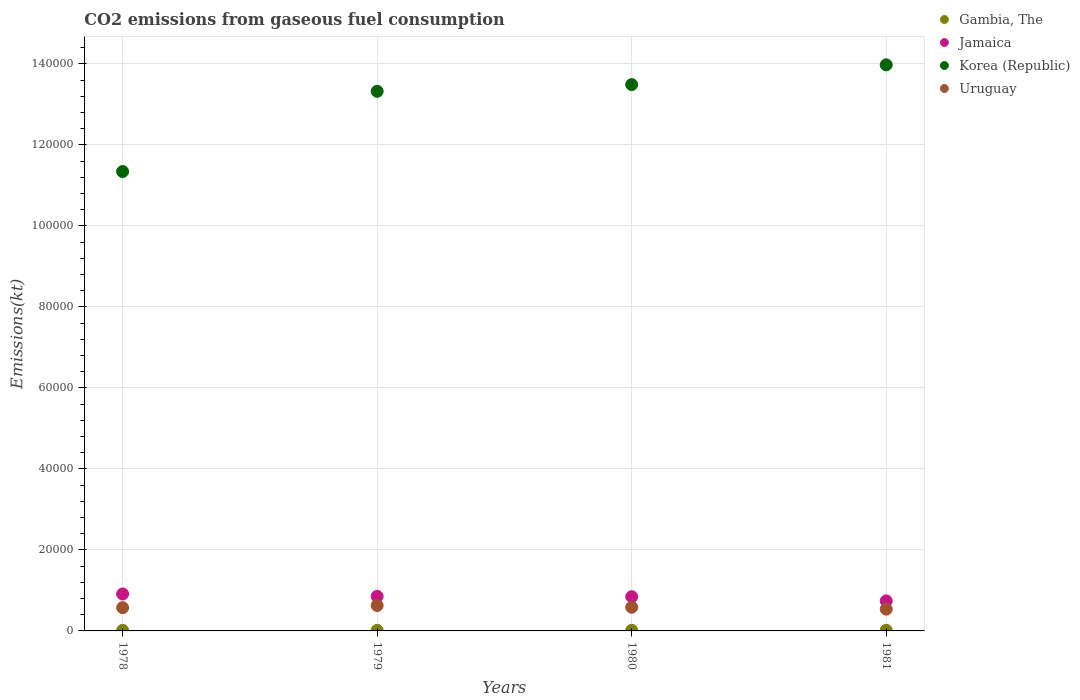What is the amount of CO2 emitted in Gambia, The in 1979?
Keep it short and to the point. 146.68. Across all years, what is the maximum amount of CO2 emitted in Gambia, The?
Your response must be concise. 157.68. Across all years, what is the minimum amount of CO2 emitted in Gambia, The?
Give a very brief answer. 139.35. In which year was the amount of CO2 emitted in Gambia, The maximum?
Provide a succinct answer. 1980. In which year was the amount of CO2 emitted in Gambia, The minimum?
Provide a succinct answer. 1978. What is the total amount of CO2 emitted in Gambia, The in the graph?
Provide a short and direct response. 601.39. What is the difference between the amount of CO2 emitted in Uruguay in 1978 and that in 1980?
Provide a succinct answer. -95.34. What is the difference between the amount of CO2 emitted in Uruguay in 1979 and the amount of CO2 emitted in Gambia, The in 1978?
Ensure brevity in your answer.  6138.56. What is the average amount of CO2 emitted in Jamaica per year?
Ensure brevity in your answer.  8380.93. In the year 1979, what is the difference between the amount of CO2 emitted in Korea (Republic) and amount of CO2 emitted in Jamaica?
Provide a succinct answer. 1.25e+05. What is the ratio of the amount of CO2 emitted in Gambia, The in 1978 to that in 1980?
Keep it short and to the point. 0.88. Is the amount of CO2 emitted in Gambia, The in 1979 less than that in 1980?
Your answer should be compact. Yes. What is the difference between the highest and the second highest amount of CO2 emitted in Jamaica?
Your answer should be compact. 583.05. What is the difference between the highest and the lowest amount of CO2 emitted in Jamaica?
Offer a terse response. 1705.15. In how many years, is the amount of CO2 emitted in Korea (Republic) greater than the average amount of CO2 emitted in Korea (Republic) taken over all years?
Offer a terse response. 3. Is the sum of the amount of CO2 emitted in Jamaica in 1979 and 1980 greater than the maximum amount of CO2 emitted in Korea (Republic) across all years?
Keep it short and to the point. No. Is it the case that in every year, the sum of the amount of CO2 emitted in Jamaica and amount of CO2 emitted in Uruguay  is greater than the amount of CO2 emitted in Korea (Republic)?
Offer a very short reply. No. Does the amount of CO2 emitted in Korea (Republic) monotonically increase over the years?
Make the answer very short. Yes. Is the amount of CO2 emitted in Gambia, The strictly greater than the amount of CO2 emitted in Uruguay over the years?
Provide a succinct answer. No. Is the amount of CO2 emitted in Jamaica strictly less than the amount of CO2 emitted in Uruguay over the years?
Provide a succinct answer. No. How many dotlines are there?
Ensure brevity in your answer.  4. What is the difference between two consecutive major ticks on the Y-axis?
Keep it short and to the point. 2.00e+04. Where does the legend appear in the graph?
Your response must be concise. Top right. How many legend labels are there?
Offer a very short reply. 4. How are the legend labels stacked?
Your response must be concise. Vertical. What is the title of the graph?
Offer a terse response. CO2 emissions from gaseous fuel consumption. Does "Hong Kong" appear as one of the legend labels in the graph?
Provide a short and direct response. No. What is the label or title of the Y-axis?
Provide a succinct answer. Emissions(kt). What is the Emissions(kt) of Gambia, The in 1978?
Offer a terse response. 139.35. What is the Emissions(kt) in Jamaica in 1978?
Make the answer very short. 9119.83. What is the Emissions(kt) in Korea (Republic) in 1978?
Offer a very short reply. 1.13e+05. What is the Emissions(kt) of Uruguay in 1978?
Your response must be concise. 5742.52. What is the Emissions(kt) of Gambia, The in 1979?
Make the answer very short. 146.68. What is the Emissions(kt) in Jamaica in 1979?
Provide a succinct answer. 8536.78. What is the Emissions(kt) in Korea (Republic) in 1979?
Provide a succinct answer. 1.33e+05. What is the Emissions(kt) of Uruguay in 1979?
Your response must be concise. 6277.9. What is the Emissions(kt) of Gambia, The in 1980?
Offer a terse response. 157.68. What is the Emissions(kt) of Jamaica in 1980?
Offer a very short reply. 8452.43. What is the Emissions(kt) in Korea (Republic) in 1980?
Your response must be concise. 1.35e+05. What is the Emissions(kt) of Uruguay in 1980?
Keep it short and to the point. 5837.86. What is the Emissions(kt) of Gambia, The in 1981?
Provide a short and direct response. 157.68. What is the Emissions(kt) of Jamaica in 1981?
Offer a very short reply. 7414.67. What is the Emissions(kt) of Korea (Republic) in 1981?
Offer a very short reply. 1.40e+05. What is the Emissions(kt) of Uruguay in 1981?
Offer a very short reply. 5375.82. Across all years, what is the maximum Emissions(kt) in Gambia, The?
Keep it short and to the point. 157.68. Across all years, what is the maximum Emissions(kt) in Jamaica?
Ensure brevity in your answer.  9119.83. Across all years, what is the maximum Emissions(kt) in Korea (Republic)?
Offer a terse response. 1.40e+05. Across all years, what is the maximum Emissions(kt) of Uruguay?
Keep it short and to the point. 6277.9. Across all years, what is the minimum Emissions(kt) in Gambia, The?
Ensure brevity in your answer.  139.35. Across all years, what is the minimum Emissions(kt) in Jamaica?
Your answer should be very brief. 7414.67. Across all years, what is the minimum Emissions(kt) in Korea (Republic)?
Offer a very short reply. 1.13e+05. Across all years, what is the minimum Emissions(kt) of Uruguay?
Provide a succinct answer. 5375.82. What is the total Emissions(kt) in Gambia, The in the graph?
Offer a very short reply. 601.39. What is the total Emissions(kt) in Jamaica in the graph?
Provide a succinct answer. 3.35e+04. What is the total Emissions(kt) of Korea (Republic) in the graph?
Your answer should be compact. 5.21e+05. What is the total Emissions(kt) in Uruguay in the graph?
Give a very brief answer. 2.32e+04. What is the difference between the Emissions(kt) in Gambia, The in 1978 and that in 1979?
Keep it short and to the point. -7.33. What is the difference between the Emissions(kt) of Jamaica in 1978 and that in 1979?
Make the answer very short. 583.05. What is the difference between the Emissions(kt) in Korea (Republic) in 1978 and that in 1979?
Make the answer very short. -1.98e+04. What is the difference between the Emissions(kt) of Uruguay in 1978 and that in 1979?
Keep it short and to the point. -535.38. What is the difference between the Emissions(kt) of Gambia, The in 1978 and that in 1980?
Provide a succinct answer. -18.34. What is the difference between the Emissions(kt) in Jamaica in 1978 and that in 1980?
Ensure brevity in your answer.  667.39. What is the difference between the Emissions(kt) of Korea (Republic) in 1978 and that in 1980?
Your answer should be compact. -2.15e+04. What is the difference between the Emissions(kt) in Uruguay in 1978 and that in 1980?
Offer a terse response. -95.34. What is the difference between the Emissions(kt) in Gambia, The in 1978 and that in 1981?
Your answer should be compact. -18.34. What is the difference between the Emissions(kt) in Jamaica in 1978 and that in 1981?
Make the answer very short. 1705.15. What is the difference between the Emissions(kt) of Korea (Republic) in 1978 and that in 1981?
Your answer should be very brief. -2.63e+04. What is the difference between the Emissions(kt) in Uruguay in 1978 and that in 1981?
Keep it short and to the point. 366.7. What is the difference between the Emissions(kt) in Gambia, The in 1979 and that in 1980?
Offer a very short reply. -11. What is the difference between the Emissions(kt) in Jamaica in 1979 and that in 1980?
Make the answer very short. 84.34. What is the difference between the Emissions(kt) in Korea (Republic) in 1979 and that in 1980?
Make the answer very short. -1657.48. What is the difference between the Emissions(kt) of Uruguay in 1979 and that in 1980?
Your answer should be very brief. 440.04. What is the difference between the Emissions(kt) of Gambia, The in 1979 and that in 1981?
Make the answer very short. -11. What is the difference between the Emissions(kt) of Jamaica in 1979 and that in 1981?
Give a very brief answer. 1122.1. What is the difference between the Emissions(kt) in Korea (Republic) in 1979 and that in 1981?
Provide a short and direct response. -6530.93. What is the difference between the Emissions(kt) in Uruguay in 1979 and that in 1981?
Give a very brief answer. 902.08. What is the difference between the Emissions(kt) of Jamaica in 1980 and that in 1981?
Ensure brevity in your answer.  1037.76. What is the difference between the Emissions(kt) of Korea (Republic) in 1980 and that in 1981?
Ensure brevity in your answer.  -4873.44. What is the difference between the Emissions(kt) of Uruguay in 1980 and that in 1981?
Make the answer very short. 462.04. What is the difference between the Emissions(kt) of Gambia, The in 1978 and the Emissions(kt) of Jamaica in 1979?
Provide a short and direct response. -8397.43. What is the difference between the Emissions(kt) in Gambia, The in 1978 and the Emissions(kt) in Korea (Republic) in 1979?
Give a very brief answer. -1.33e+05. What is the difference between the Emissions(kt) of Gambia, The in 1978 and the Emissions(kt) of Uruguay in 1979?
Give a very brief answer. -6138.56. What is the difference between the Emissions(kt) of Jamaica in 1978 and the Emissions(kt) of Korea (Republic) in 1979?
Give a very brief answer. -1.24e+05. What is the difference between the Emissions(kt) of Jamaica in 1978 and the Emissions(kt) of Uruguay in 1979?
Your answer should be very brief. 2841.93. What is the difference between the Emissions(kt) in Korea (Republic) in 1978 and the Emissions(kt) in Uruguay in 1979?
Ensure brevity in your answer.  1.07e+05. What is the difference between the Emissions(kt) in Gambia, The in 1978 and the Emissions(kt) in Jamaica in 1980?
Your answer should be compact. -8313.09. What is the difference between the Emissions(kt) in Gambia, The in 1978 and the Emissions(kt) in Korea (Republic) in 1980?
Offer a very short reply. -1.35e+05. What is the difference between the Emissions(kt) in Gambia, The in 1978 and the Emissions(kt) in Uruguay in 1980?
Give a very brief answer. -5698.52. What is the difference between the Emissions(kt) of Jamaica in 1978 and the Emissions(kt) of Korea (Republic) in 1980?
Offer a terse response. -1.26e+05. What is the difference between the Emissions(kt) of Jamaica in 1978 and the Emissions(kt) of Uruguay in 1980?
Your response must be concise. 3281.97. What is the difference between the Emissions(kt) of Korea (Republic) in 1978 and the Emissions(kt) of Uruguay in 1980?
Your answer should be compact. 1.08e+05. What is the difference between the Emissions(kt) of Gambia, The in 1978 and the Emissions(kt) of Jamaica in 1981?
Your response must be concise. -7275.33. What is the difference between the Emissions(kt) of Gambia, The in 1978 and the Emissions(kt) of Korea (Republic) in 1981?
Ensure brevity in your answer.  -1.40e+05. What is the difference between the Emissions(kt) of Gambia, The in 1978 and the Emissions(kt) of Uruguay in 1981?
Provide a succinct answer. -5236.48. What is the difference between the Emissions(kt) in Jamaica in 1978 and the Emissions(kt) in Korea (Republic) in 1981?
Keep it short and to the point. -1.31e+05. What is the difference between the Emissions(kt) in Jamaica in 1978 and the Emissions(kt) in Uruguay in 1981?
Offer a terse response. 3744.01. What is the difference between the Emissions(kt) of Korea (Republic) in 1978 and the Emissions(kt) of Uruguay in 1981?
Your answer should be very brief. 1.08e+05. What is the difference between the Emissions(kt) of Gambia, The in 1979 and the Emissions(kt) of Jamaica in 1980?
Provide a succinct answer. -8305.75. What is the difference between the Emissions(kt) in Gambia, The in 1979 and the Emissions(kt) in Korea (Republic) in 1980?
Your answer should be very brief. -1.35e+05. What is the difference between the Emissions(kt) of Gambia, The in 1979 and the Emissions(kt) of Uruguay in 1980?
Your answer should be compact. -5691.18. What is the difference between the Emissions(kt) in Jamaica in 1979 and the Emissions(kt) in Korea (Republic) in 1980?
Provide a succinct answer. -1.26e+05. What is the difference between the Emissions(kt) of Jamaica in 1979 and the Emissions(kt) of Uruguay in 1980?
Provide a succinct answer. 2698.91. What is the difference between the Emissions(kt) of Korea (Republic) in 1979 and the Emissions(kt) of Uruguay in 1980?
Offer a very short reply. 1.27e+05. What is the difference between the Emissions(kt) in Gambia, The in 1979 and the Emissions(kt) in Jamaica in 1981?
Provide a succinct answer. -7267.99. What is the difference between the Emissions(kt) of Gambia, The in 1979 and the Emissions(kt) of Korea (Republic) in 1981?
Your answer should be very brief. -1.40e+05. What is the difference between the Emissions(kt) in Gambia, The in 1979 and the Emissions(kt) in Uruguay in 1981?
Provide a short and direct response. -5229.14. What is the difference between the Emissions(kt) of Jamaica in 1979 and the Emissions(kt) of Korea (Republic) in 1981?
Ensure brevity in your answer.  -1.31e+05. What is the difference between the Emissions(kt) of Jamaica in 1979 and the Emissions(kt) of Uruguay in 1981?
Give a very brief answer. 3160.95. What is the difference between the Emissions(kt) of Korea (Republic) in 1979 and the Emissions(kt) of Uruguay in 1981?
Offer a very short reply. 1.28e+05. What is the difference between the Emissions(kt) of Gambia, The in 1980 and the Emissions(kt) of Jamaica in 1981?
Your response must be concise. -7256.99. What is the difference between the Emissions(kt) of Gambia, The in 1980 and the Emissions(kt) of Korea (Republic) in 1981?
Provide a succinct answer. -1.40e+05. What is the difference between the Emissions(kt) of Gambia, The in 1980 and the Emissions(kt) of Uruguay in 1981?
Your response must be concise. -5218.14. What is the difference between the Emissions(kt) of Jamaica in 1980 and the Emissions(kt) of Korea (Republic) in 1981?
Your response must be concise. -1.31e+05. What is the difference between the Emissions(kt) in Jamaica in 1980 and the Emissions(kt) in Uruguay in 1981?
Give a very brief answer. 3076.61. What is the difference between the Emissions(kt) of Korea (Republic) in 1980 and the Emissions(kt) of Uruguay in 1981?
Provide a short and direct response. 1.29e+05. What is the average Emissions(kt) in Gambia, The per year?
Your response must be concise. 150.35. What is the average Emissions(kt) of Jamaica per year?
Make the answer very short. 8380.93. What is the average Emissions(kt) in Korea (Republic) per year?
Make the answer very short. 1.30e+05. What is the average Emissions(kt) of Uruguay per year?
Your response must be concise. 5808.53. In the year 1978, what is the difference between the Emissions(kt) in Gambia, The and Emissions(kt) in Jamaica?
Give a very brief answer. -8980.48. In the year 1978, what is the difference between the Emissions(kt) in Gambia, The and Emissions(kt) in Korea (Republic)?
Your answer should be compact. -1.13e+05. In the year 1978, what is the difference between the Emissions(kt) in Gambia, The and Emissions(kt) in Uruguay?
Provide a succinct answer. -5603.18. In the year 1978, what is the difference between the Emissions(kt) in Jamaica and Emissions(kt) in Korea (Republic)?
Your answer should be compact. -1.04e+05. In the year 1978, what is the difference between the Emissions(kt) of Jamaica and Emissions(kt) of Uruguay?
Your answer should be very brief. 3377.31. In the year 1978, what is the difference between the Emissions(kt) in Korea (Republic) and Emissions(kt) in Uruguay?
Provide a succinct answer. 1.08e+05. In the year 1979, what is the difference between the Emissions(kt) in Gambia, The and Emissions(kt) in Jamaica?
Ensure brevity in your answer.  -8390.1. In the year 1979, what is the difference between the Emissions(kt) of Gambia, The and Emissions(kt) of Korea (Republic)?
Offer a very short reply. -1.33e+05. In the year 1979, what is the difference between the Emissions(kt) in Gambia, The and Emissions(kt) in Uruguay?
Provide a short and direct response. -6131.22. In the year 1979, what is the difference between the Emissions(kt) in Jamaica and Emissions(kt) in Korea (Republic)?
Ensure brevity in your answer.  -1.25e+05. In the year 1979, what is the difference between the Emissions(kt) in Jamaica and Emissions(kt) in Uruguay?
Offer a terse response. 2258.87. In the year 1979, what is the difference between the Emissions(kt) in Korea (Republic) and Emissions(kt) in Uruguay?
Offer a very short reply. 1.27e+05. In the year 1980, what is the difference between the Emissions(kt) of Gambia, The and Emissions(kt) of Jamaica?
Keep it short and to the point. -8294.75. In the year 1980, what is the difference between the Emissions(kt) of Gambia, The and Emissions(kt) of Korea (Republic)?
Make the answer very short. -1.35e+05. In the year 1980, what is the difference between the Emissions(kt) in Gambia, The and Emissions(kt) in Uruguay?
Your response must be concise. -5680.18. In the year 1980, what is the difference between the Emissions(kt) in Jamaica and Emissions(kt) in Korea (Republic)?
Provide a succinct answer. -1.26e+05. In the year 1980, what is the difference between the Emissions(kt) in Jamaica and Emissions(kt) in Uruguay?
Provide a succinct answer. 2614.57. In the year 1980, what is the difference between the Emissions(kt) in Korea (Republic) and Emissions(kt) in Uruguay?
Offer a terse response. 1.29e+05. In the year 1981, what is the difference between the Emissions(kt) in Gambia, The and Emissions(kt) in Jamaica?
Offer a very short reply. -7256.99. In the year 1981, what is the difference between the Emissions(kt) of Gambia, The and Emissions(kt) of Korea (Republic)?
Your answer should be compact. -1.40e+05. In the year 1981, what is the difference between the Emissions(kt) in Gambia, The and Emissions(kt) in Uruguay?
Your answer should be very brief. -5218.14. In the year 1981, what is the difference between the Emissions(kt) in Jamaica and Emissions(kt) in Korea (Republic)?
Your response must be concise. -1.32e+05. In the year 1981, what is the difference between the Emissions(kt) in Jamaica and Emissions(kt) in Uruguay?
Keep it short and to the point. 2038.85. In the year 1981, what is the difference between the Emissions(kt) of Korea (Republic) and Emissions(kt) of Uruguay?
Your response must be concise. 1.34e+05. What is the ratio of the Emissions(kt) of Jamaica in 1978 to that in 1979?
Ensure brevity in your answer.  1.07. What is the ratio of the Emissions(kt) of Korea (Republic) in 1978 to that in 1979?
Provide a short and direct response. 0.85. What is the ratio of the Emissions(kt) of Uruguay in 1978 to that in 1979?
Your answer should be compact. 0.91. What is the ratio of the Emissions(kt) of Gambia, The in 1978 to that in 1980?
Your response must be concise. 0.88. What is the ratio of the Emissions(kt) of Jamaica in 1978 to that in 1980?
Make the answer very short. 1.08. What is the ratio of the Emissions(kt) of Korea (Republic) in 1978 to that in 1980?
Offer a very short reply. 0.84. What is the ratio of the Emissions(kt) in Uruguay in 1978 to that in 1980?
Offer a terse response. 0.98. What is the ratio of the Emissions(kt) of Gambia, The in 1978 to that in 1981?
Your answer should be very brief. 0.88. What is the ratio of the Emissions(kt) of Jamaica in 1978 to that in 1981?
Your answer should be compact. 1.23. What is the ratio of the Emissions(kt) of Korea (Republic) in 1978 to that in 1981?
Ensure brevity in your answer.  0.81. What is the ratio of the Emissions(kt) in Uruguay in 1978 to that in 1981?
Provide a succinct answer. 1.07. What is the ratio of the Emissions(kt) of Gambia, The in 1979 to that in 1980?
Ensure brevity in your answer.  0.93. What is the ratio of the Emissions(kt) of Jamaica in 1979 to that in 1980?
Make the answer very short. 1.01. What is the ratio of the Emissions(kt) in Korea (Republic) in 1979 to that in 1980?
Offer a terse response. 0.99. What is the ratio of the Emissions(kt) of Uruguay in 1979 to that in 1980?
Provide a succinct answer. 1.08. What is the ratio of the Emissions(kt) of Gambia, The in 1979 to that in 1981?
Offer a terse response. 0.93. What is the ratio of the Emissions(kt) of Jamaica in 1979 to that in 1981?
Your answer should be very brief. 1.15. What is the ratio of the Emissions(kt) in Korea (Republic) in 1979 to that in 1981?
Your answer should be very brief. 0.95. What is the ratio of the Emissions(kt) in Uruguay in 1979 to that in 1981?
Your response must be concise. 1.17. What is the ratio of the Emissions(kt) of Jamaica in 1980 to that in 1981?
Ensure brevity in your answer.  1.14. What is the ratio of the Emissions(kt) in Korea (Republic) in 1980 to that in 1981?
Your answer should be very brief. 0.97. What is the ratio of the Emissions(kt) in Uruguay in 1980 to that in 1981?
Provide a short and direct response. 1.09. What is the difference between the highest and the second highest Emissions(kt) in Gambia, The?
Ensure brevity in your answer.  0. What is the difference between the highest and the second highest Emissions(kt) in Jamaica?
Your response must be concise. 583.05. What is the difference between the highest and the second highest Emissions(kt) of Korea (Republic)?
Make the answer very short. 4873.44. What is the difference between the highest and the second highest Emissions(kt) in Uruguay?
Make the answer very short. 440.04. What is the difference between the highest and the lowest Emissions(kt) in Gambia, The?
Your response must be concise. 18.34. What is the difference between the highest and the lowest Emissions(kt) of Jamaica?
Give a very brief answer. 1705.15. What is the difference between the highest and the lowest Emissions(kt) of Korea (Republic)?
Offer a very short reply. 2.63e+04. What is the difference between the highest and the lowest Emissions(kt) in Uruguay?
Give a very brief answer. 902.08. 